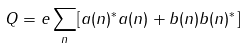Convert formula to latex. <formula><loc_0><loc_0><loc_500><loc_500>Q = e \sum _ { n } [ a ( n ) ^ { * } a ( n ) + b ( n ) b ( n ) ^ { * } ]</formula> 